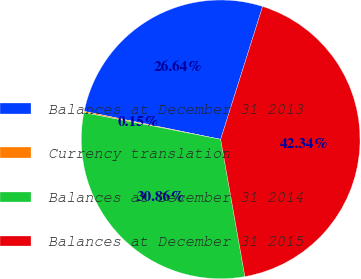Convert chart. <chart><loc_0><loc_0><loc_500><loc_500><pie_chart><fcel>Balances at December 31 2013<fcel>Currency translation<fcel>Balances at December 31 2014<fcel>Balances at December 31 2015<nl><fcel>26.64%<fcel>0.15%<fcel>30.86%<fcel>42.34%<nl></chart> 